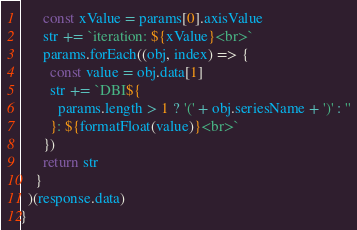Convert code to text. <code><loc_0><loc_0><loc_500><loc_500><_JavaScript_>      const xValue = params[0].axisValue
      str += `iteration: ${xValue}<br>`
      params.forEach((obj, index) => {
        const value = obj.data[1]
        str += `DBI${
          params.length > 1 ? '(' + obj.seriesName + ')' : ''
        }: ${formatFloat(value)}<br>`
      })
      return str
    }
  )(response.data)
}

</code> 